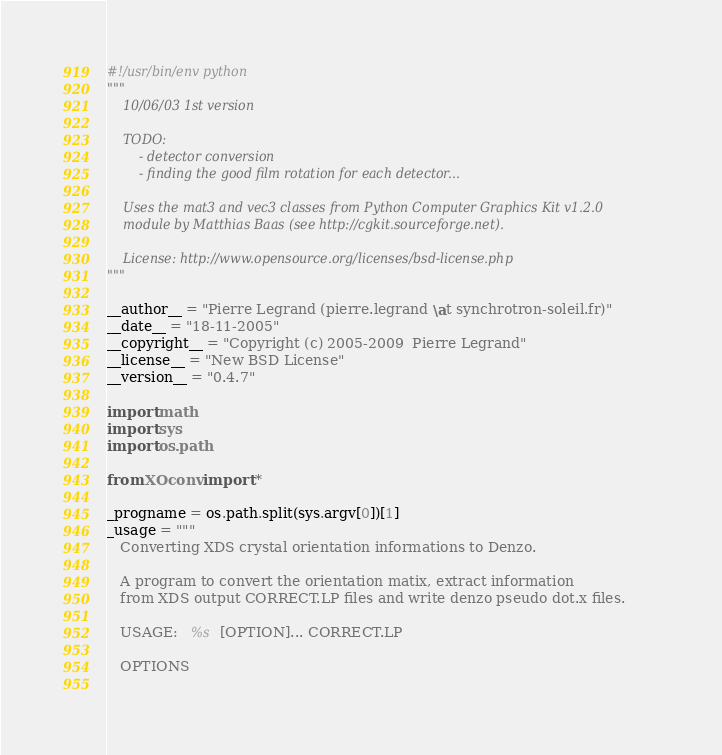Convert code to text. <code><loc_0><loc_0><loc_500><loc_500><_Python_>#!/usr/bin/env python
"""
    10/06/03 1st version
    
    TODO:
        - detector conversion
        - finding the good film rotation for each detector...
    
    Uses the mat3 and vec3 classes from Python Computer Graphics Kit v1.2.0
    module by Matthias Baas (see http://cgkit.sourceforge.net).
    
    License: http://www.opensource.org/licenses/bsd-license.php
"""

__author__ = "Pierre Legrand (pierre.legrand \at synchrotron-soleil.fr)"
__date__ = "18-11-2005"
__copyright__ = "Copyright (c) 2005-2009  Pierre Legrand"
__license__ = "New BSD License"
__version__ = "0.4.7"

import math
import sys
import os.path

from XOconv import *

_progname = os.path.split(sys.argv[0])[1]
_usage = """
   Converting XDS crystal orientation informations to Denzo.

   A program to convert the orientation matix, extract information
   from XDS output CORRECT.LP files and write denzo pseudo dot.x files.

   USAGE:   %s  [OPTION]... CORRECT.LP
    
   OPTIONS
    </code> 